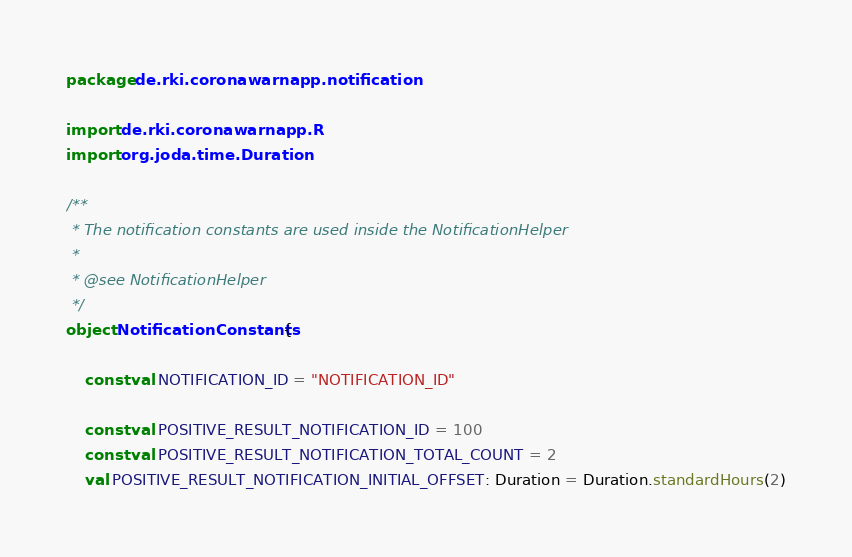Convert code to text. <code><loc_0><loc_0><loc_500><loc_500><_Kotlin_>package de.rki.coronawarnapp.notification

import de.rki.coronawarnapp.R
import org.joda.time.Duration

/**
 * The notification constants are used inside the NotificationHelper
 *
 * @see NotificationHelper
 */
object NotificationConstants {

    const val NOTIFICATION_ID = "NOTIFICATION_ID"

    const val POSITIVE_RESULT_NOTIFICATION_ID = 100
    const val POSITIVE_RESULT_NOTIFICATION_TOTAL_COUNT = 2
    val POSITIVE_RESULT_NOTIFICATION_INITIAL_OFFSET: Duration = Duration.standardHours(2)</code> 